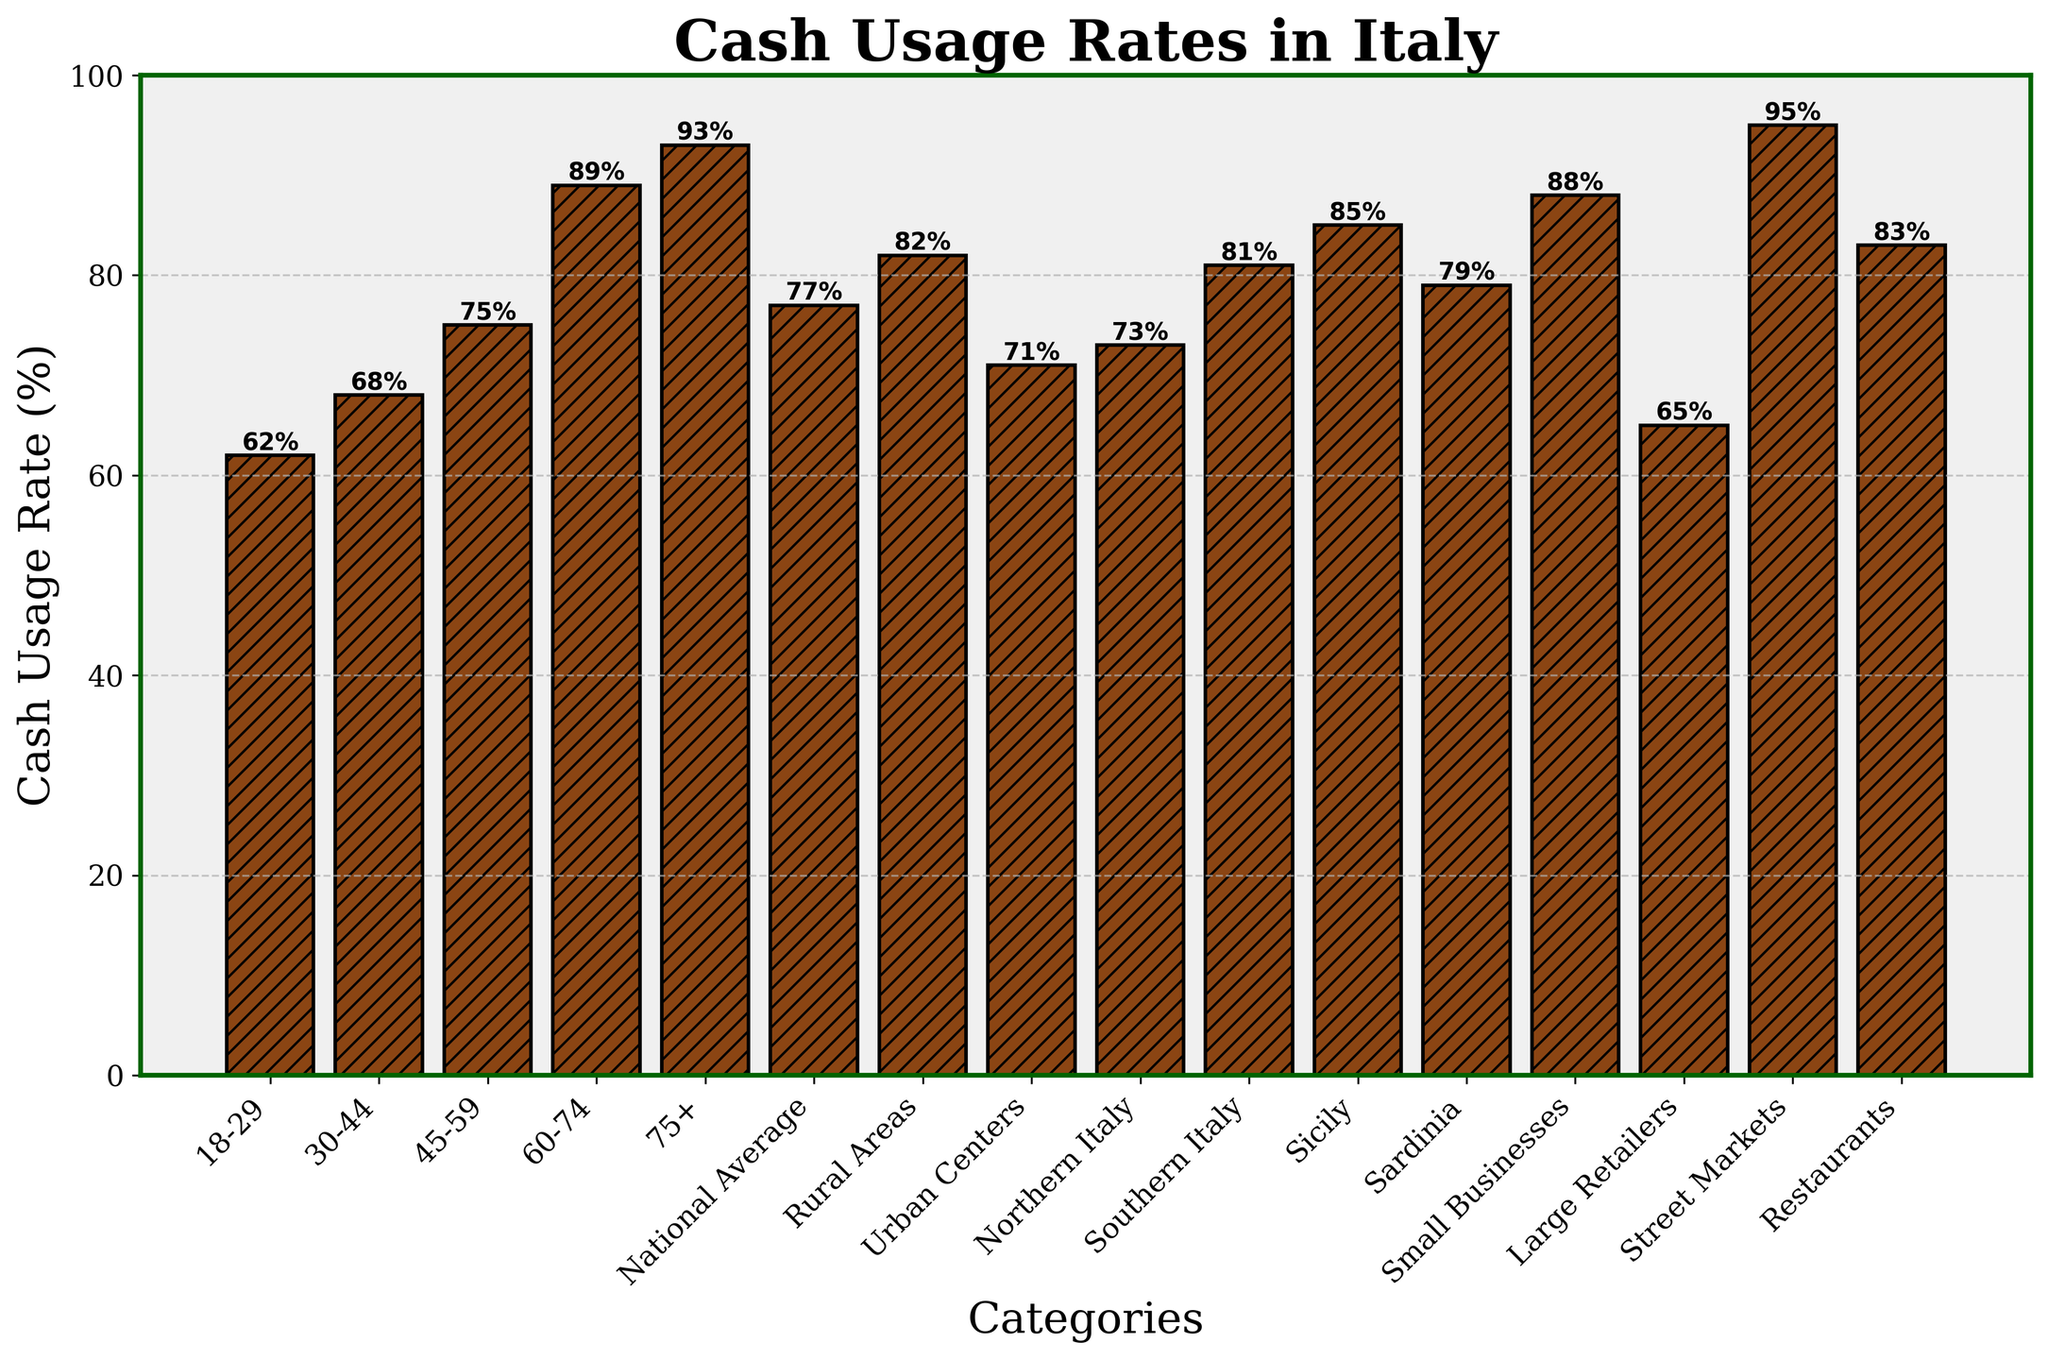Which age group has the highest cash usage rate? Observing the height of the bars, the age group 75+ has the highest cash usage rate shown by the tallest bar.
Answer: 75+ Is the cash usage rate higher in rural areas or urban centers? Comparing the bars representing rural areas and urban centers, the bar for rural areas is taller, indicating a higher cash usage rate.
Answer: Rural areas What is the difference in cash usage rate between large retailers and street markets? The cash usage rate for large retailers is 65%, while for street markets it is 95%. The difference is 95% - 65% = 30%.
Answer: 30% How much higher is the national average compared to Northern Italy? The national average cash usage rate is 77%, and for Northern Italy it is 73%. The difference is 77% - 73% = 4%.
Answer: 4% Which category has the lowest cash usage rate, and what is its value? The shortest bar represents large retailers with the lowest cash usage rate of 65%.
Answer: Large retailers, 65% Rank the age groups from highest to lowest cash usage rate. The bars show the following order based on height: 75+ (93%), 60-74 (89%), 45-59 (75%), 30-44 (68%), 18-29 (62%).
Answer: 75+, 60-74, 45-59, 30-44, 18-29 Are small businesses' cash usage rates higher than the national average? The bar for small businesses shows a cash usage rate of 88%, which is higher than the national average of 77%.
Answer: Yes Which has a higher cash usage rate: Sardinia or Sicily? Comparing the bars, Sicily has a higher cash usage rate of 85% compared to Sardinia’s 79%.
Answer: Sicily Calculate the average cash usage rate for the regions: Rural Areas, Urban Centers, Northern Italy, Southern Italy, Sicily, and Sardinia. Adding the rates: 82% (Rural Areas) + 71% (Urban Centers) + 73% (Northern Italy) + 81% (Southern Italy) + 85% (Sicily) + 79% (Sardinia) = 471%. Dividing by the number of regions: 471% / 6 ≈ 78.5%.
Answer: 78.5% 